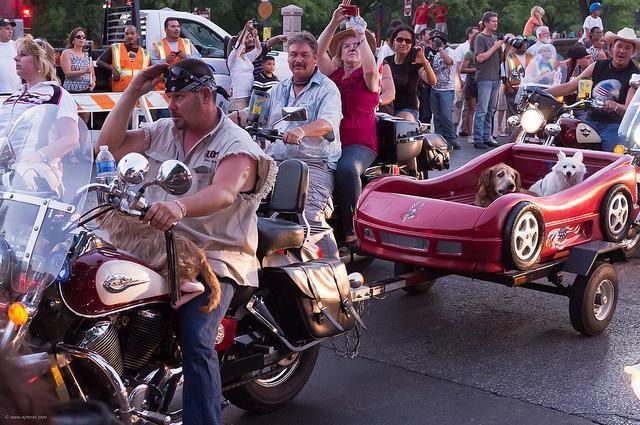How many people are in the picture?
Give a very brief answer. 7. How many motorcycles are there?
Give a very brief answer. 3. How many brown horses are jumping in this photo?
Give a very brief answer. 0. 